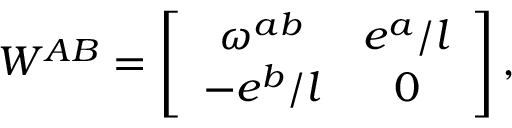Convert formula to latex. <formula><loc_0><loc_0><loc_500><loc_500>W ^ { A B } = \left [ \begin{array} { c c } { { \omega ^ { a b } } } & { { e ^ { a } / l } } \\ { { - e ^ { b } / l } } & { 0 } \end{array} \right ] ,</formula> 